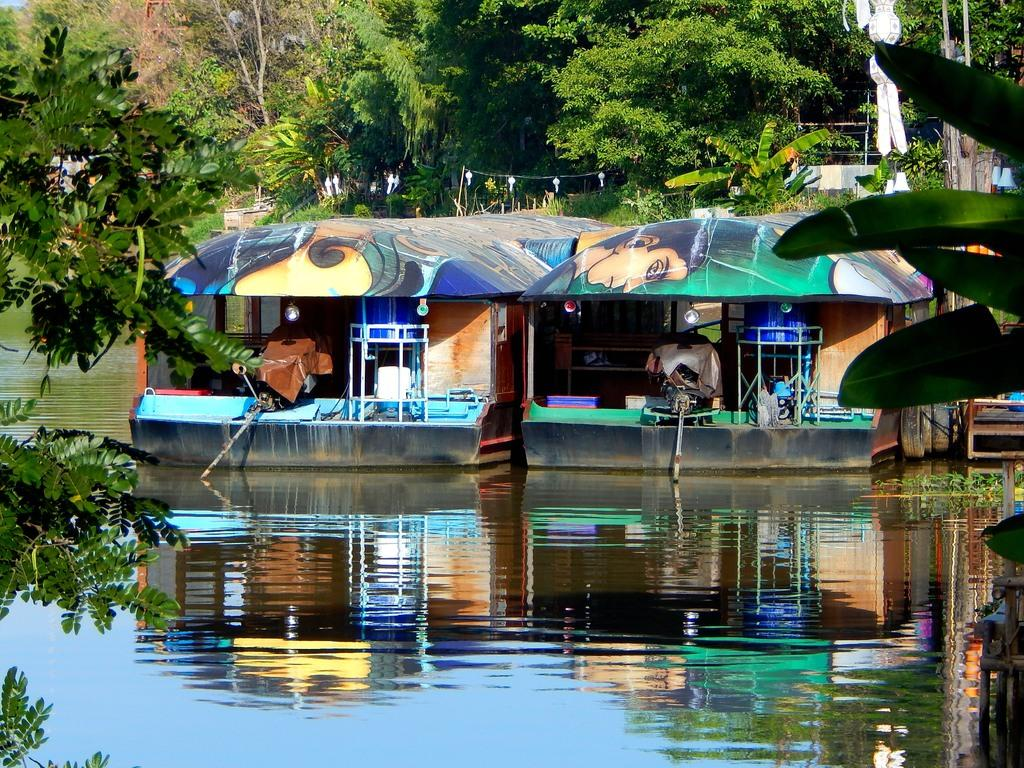What is the main feature in the image? There is a water body in the image. What can be seen in the center of the water body? There are boats in the center of the image. What is visible in the background of the image? There are trees and plants in the background of the image. What is present in the foreground of the image? There are branches of trees in the foreground of the image. What type of steel structure can be seen in the image? There is no steel structure present in the image; it features a water body with boats, trees, and plants. 